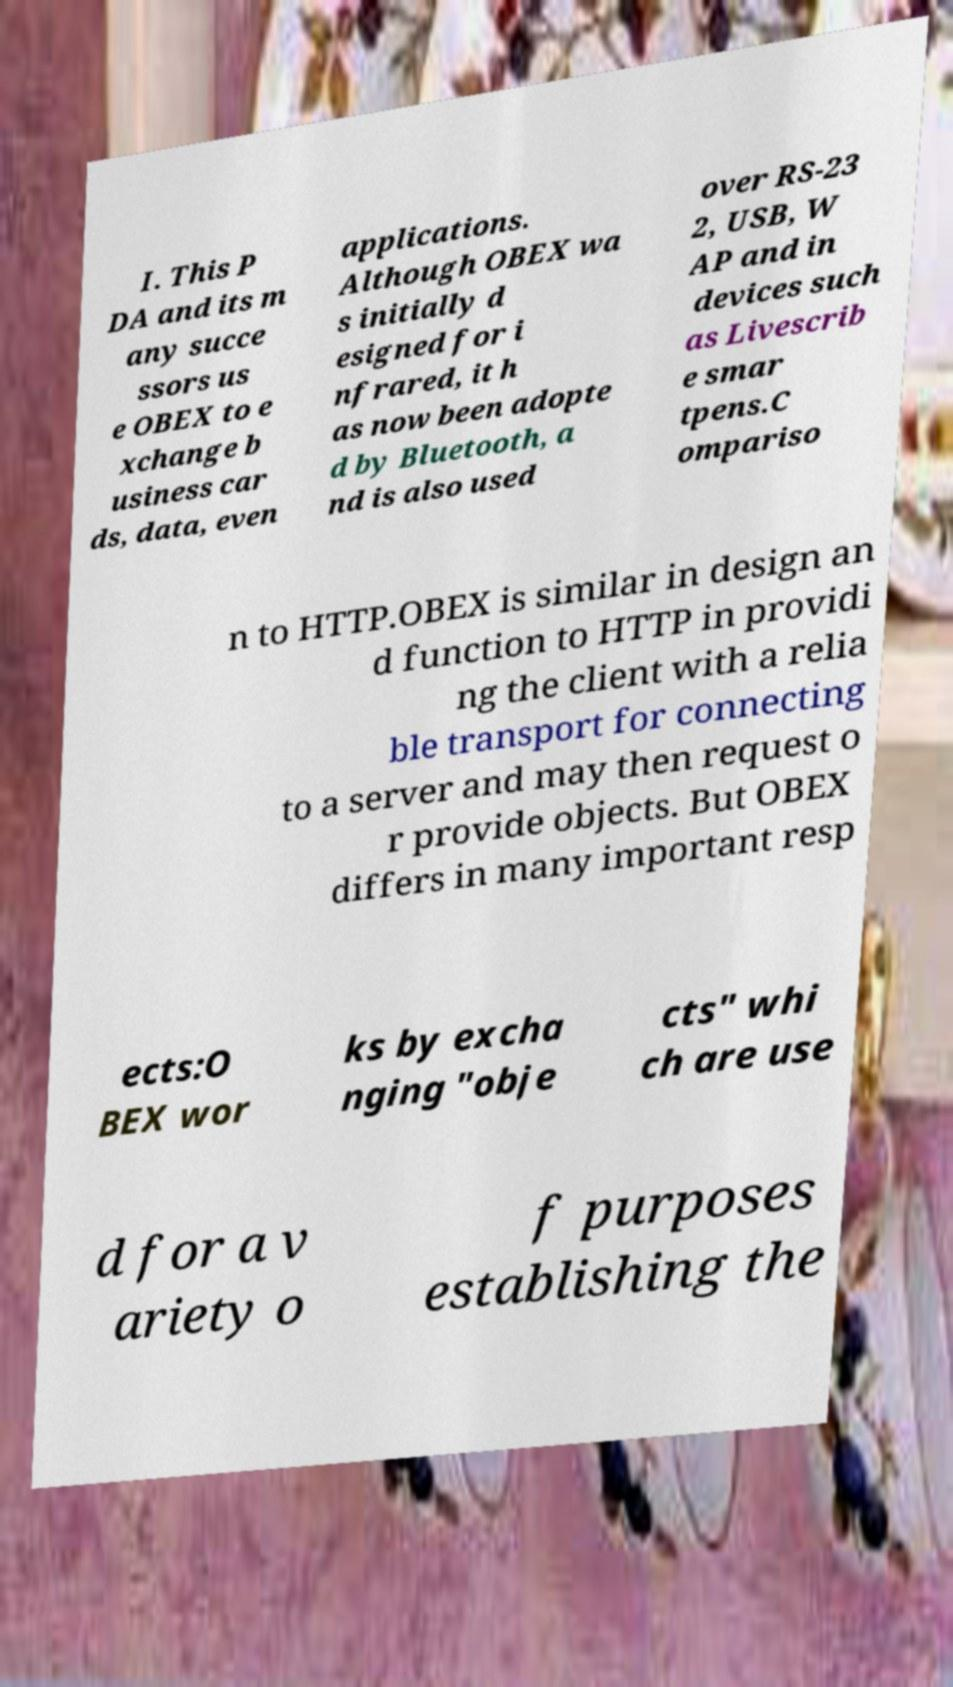Can you accurately transcribe the text from the provided image for me? I. This P DA and its m any succe ssors us e OBEX to e xchange b usiness car ds, data, even applications. Although OBEX wa s initially d esigned for i nfrared, it h as now been adopte d by Bluetooth, a nd is also used over RS-23 2, USB, W AP and in devices such as Livescrib e smar tpens.C ompariso n to HTTP.OBEX is similar in design an d function to HTTP in providi ng the client with a relia ble transport for connecting to a server and may then request o r provide objects. But OBEX differs in many important resp ects:O BEX wor ks by excha nging "obje cts" whi ch are use d for a v ariety o f purposes establishing the 